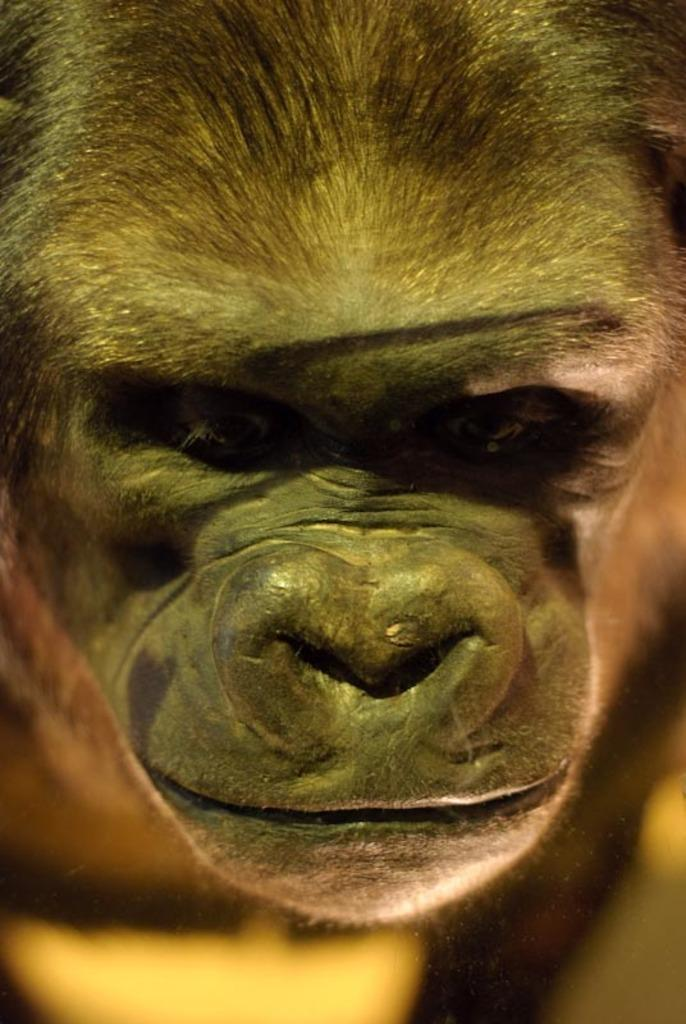What type of animal is in the picture? There is a monkey in the picture. What features can be seen on the monkey's face? The monkey has a mouth and an eye. What type of covering does the monkey have on its body? The monkey has hair on its body. How does the monkey contribute to the development of the middle class in the image? There is no indication of class or development in the image; it simply features a monkey. 